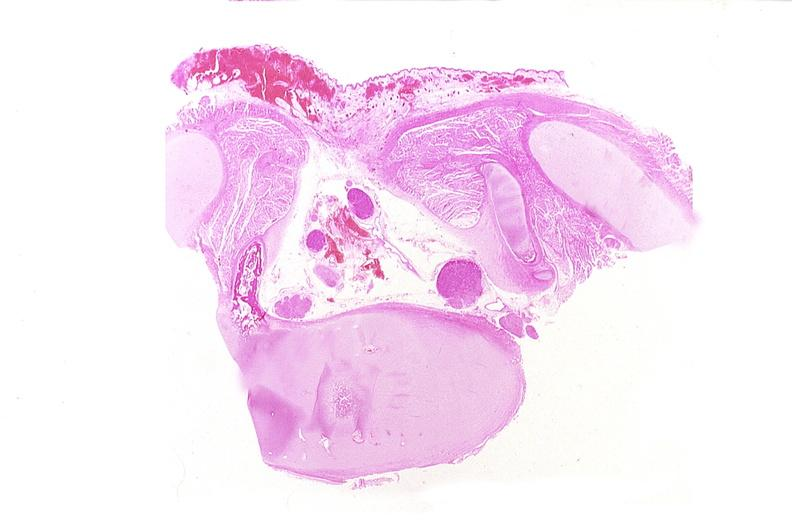does this image show neural tube defect, meningomyelocele?
Answer the question using a single word or phrase. Yes 